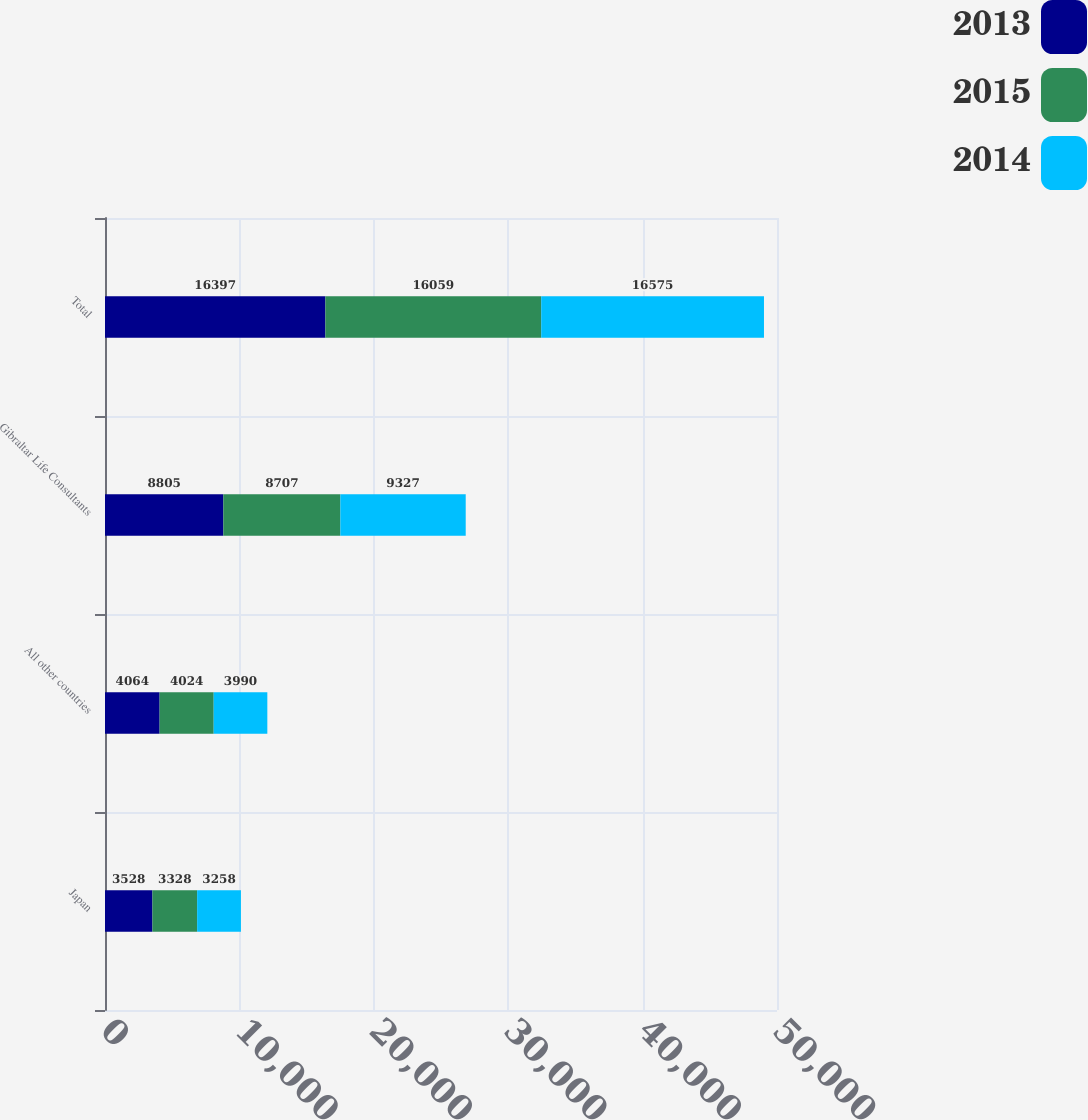Convert chart to OTSL. <chart><loc_0><loc_0><loc_500><loc_500><stacked_bar_chart><ecel><fcel>Japan<fcel>All other countries<fcel>Gibraltar Life Consultants<fcel>Total<nl><fcel>2013<fcel>3528<fcel>4064<fcel>8805<fcel>16397<nl><fcel>2015<fcel>3328<fcel>4024<fcel>8707<fcel>16059<nl><fcel>2014<fcel>3258<fcel>3990<fcel>9327<fcel>16575<nl></chart> 